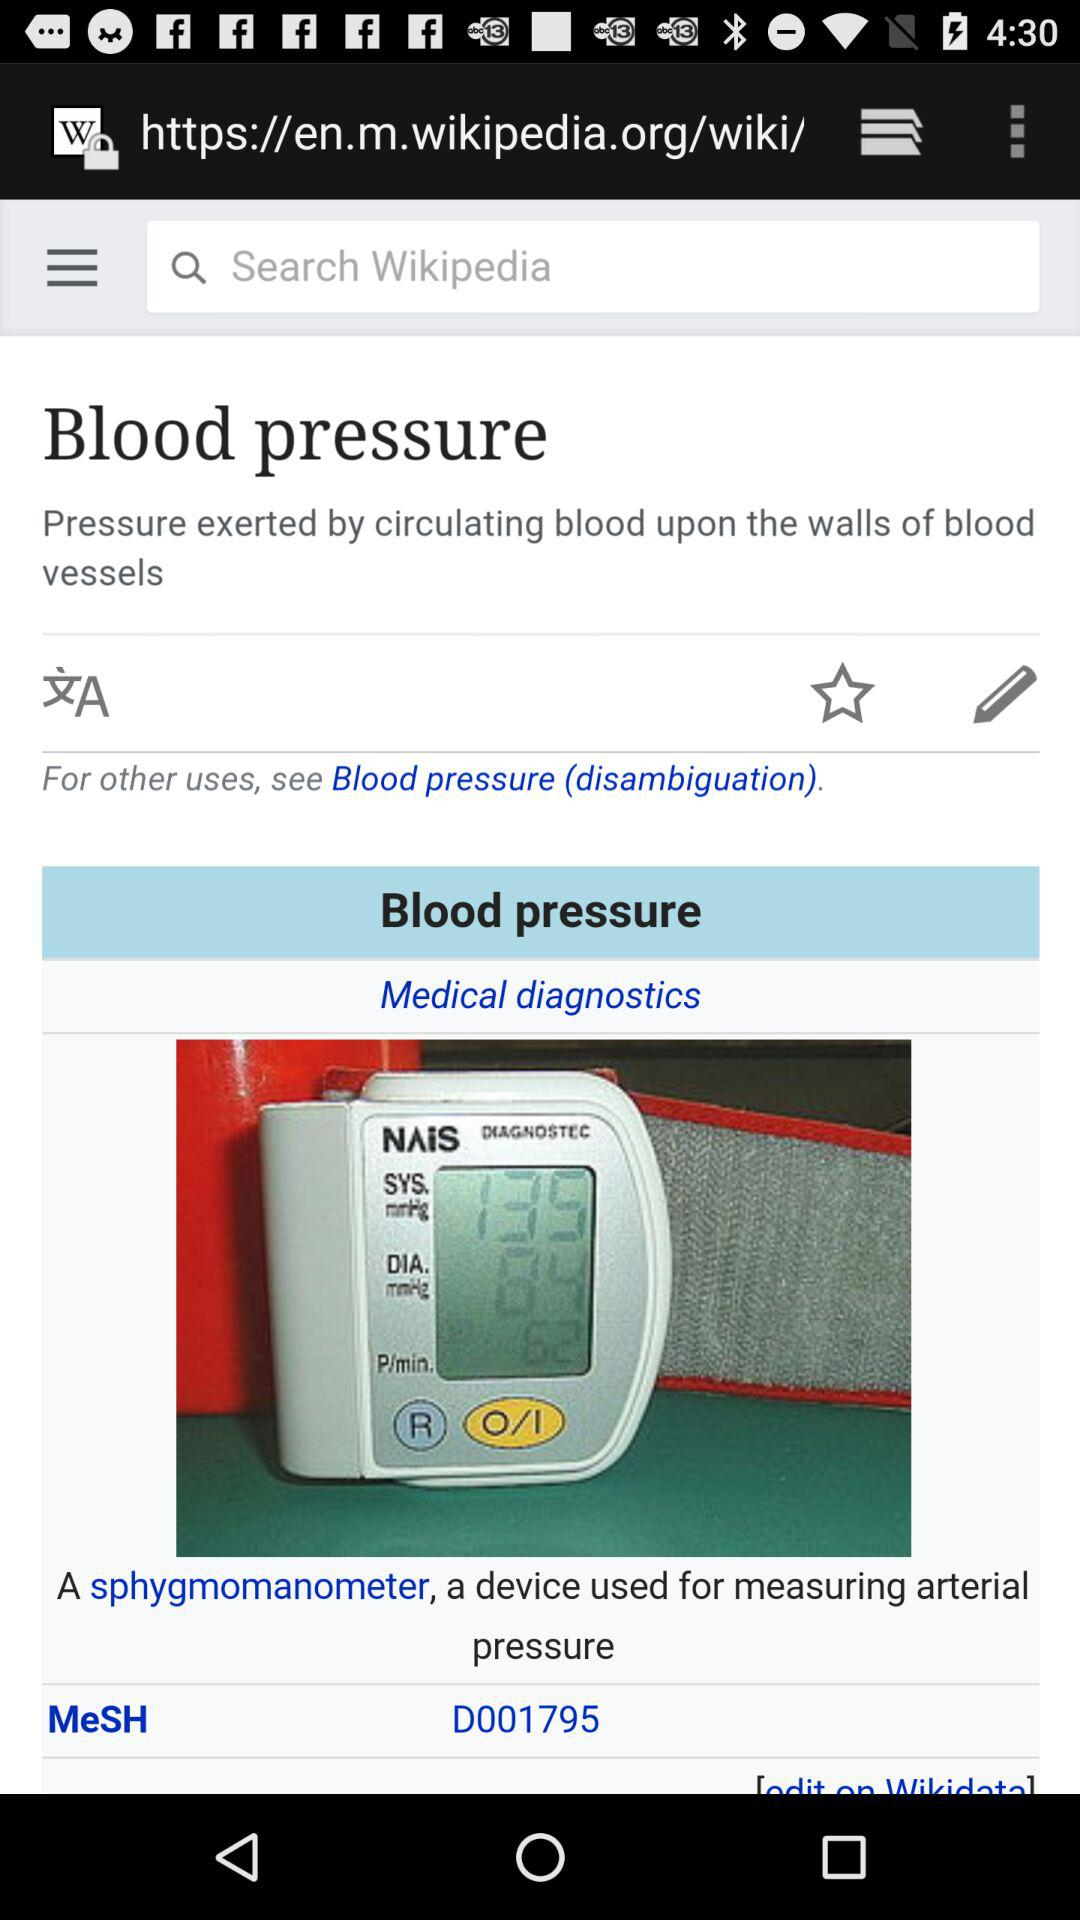What is the name of the gadget that measures arterial pressure? The name of the gadget is "sphygmomanometer". 